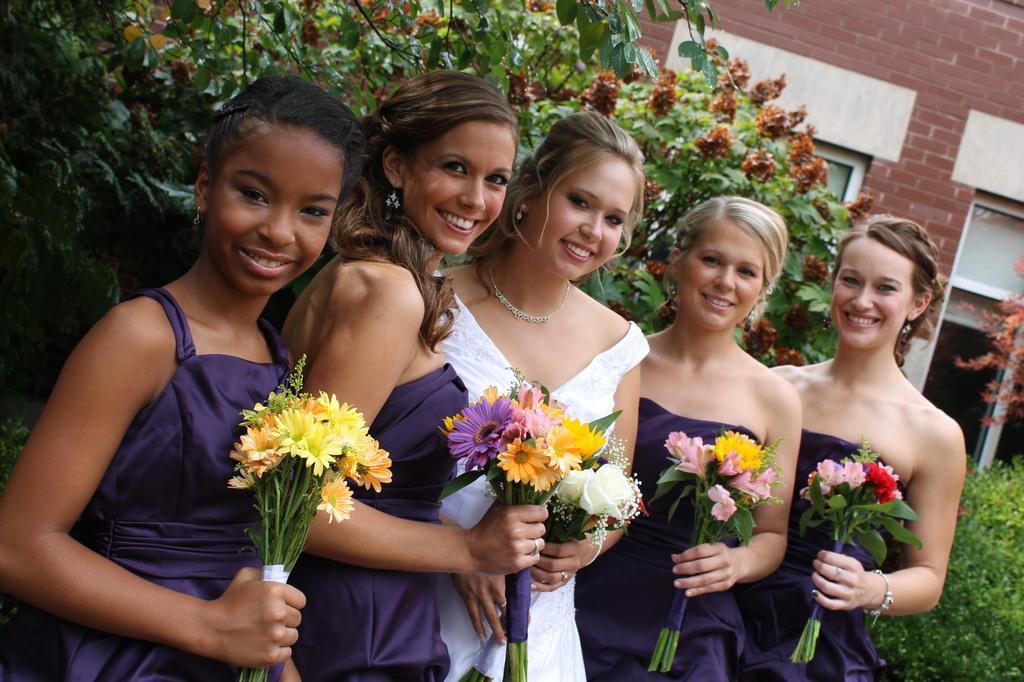Describe this image in one or two sentences. This image is taken outdoors. In the background there is a building and there are a few trees and plants on the ground. In the middle of the image five women are standing on the ground. They are with smiling faces and they are holding bouquets in their hands. 